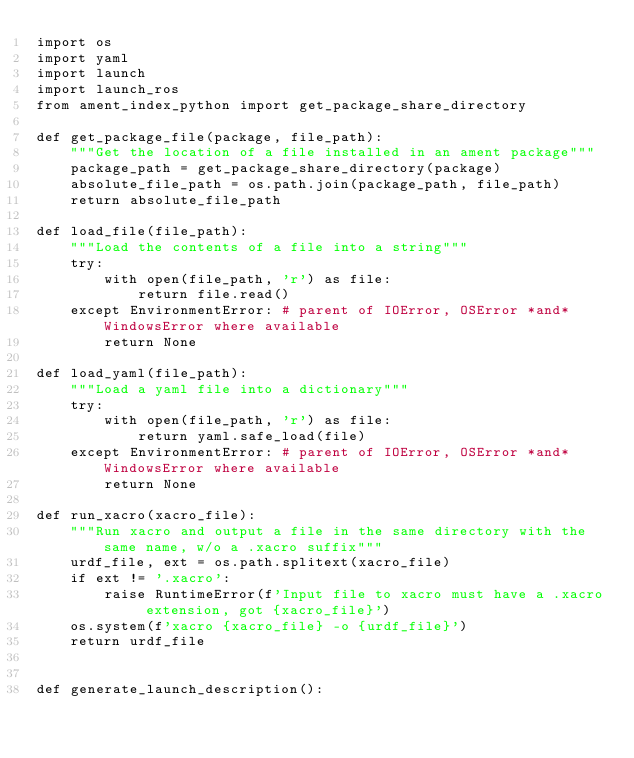<code> <loc_0><loc_0><loc_500><loc_500><_Python_>import os
import yaml
import launch
import launch_ros
from ament_index_python import get_package_share_directory

def get_package_file(package, file_path):
    """Get the location of a file installed in an ament package"""
    package_path = get_package_share_directory(package)
    absolute_file_path = os.path.join(package_path, file_path)
    return absolute_file_path

def load_file(file_path):
    """Load the contents of a file into a string"""
    try:
        with open(file_path, 'r') as file:
            return file.read()
    except EnvironmentError: # parent of IOError, OSError *and* WindowsError where available
        return None

def load_yaml(file_path):
    """Load a yaml file into a dictionary"""
    try:
        with open(file_path, 'r') as file:
            return yaml.safe_load(file)
    except EnvironmentError: # parent of IOError, OSError *and* WindowsError where available
        return None

def run_xacro(xacro_file):
    """Run xacro and output a file in the same directory with the same name, w/o a .xacro suffix"""
    urdf_file, ext = os.path.splitext(xacro_file)
    if ext != '.xacro':
        raise RuntimeError(f'Input file to xacro must have a .xacro extension, got {xacro_file}')
    os.system(f'xacro {xacro_file} -o {urdf_file}')
    return urdf_file


def generate_launch_description():</code> 